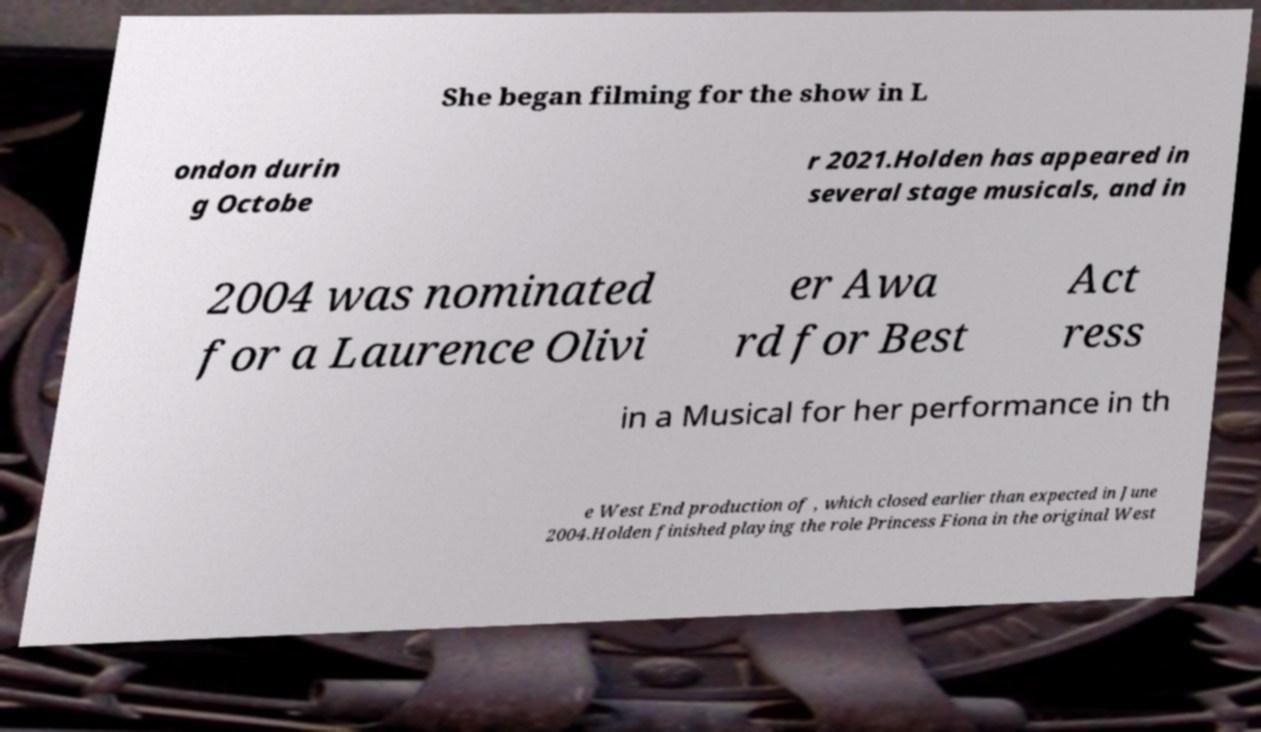There's text embedded in this image that I need extracted. Can you transcribe it verbatim? She began filming for the show in L ondon durin g Octobe r 2021.Holden has appeared in several stage musicals, and in 2004 was nominated for a Laurence Olivi er Awa rd for Best Act ress in a Musical for her performance in th e West End production of , which closed earlier than expected in June 2004.Holden finished playing the role Princess Fiona in the original West 